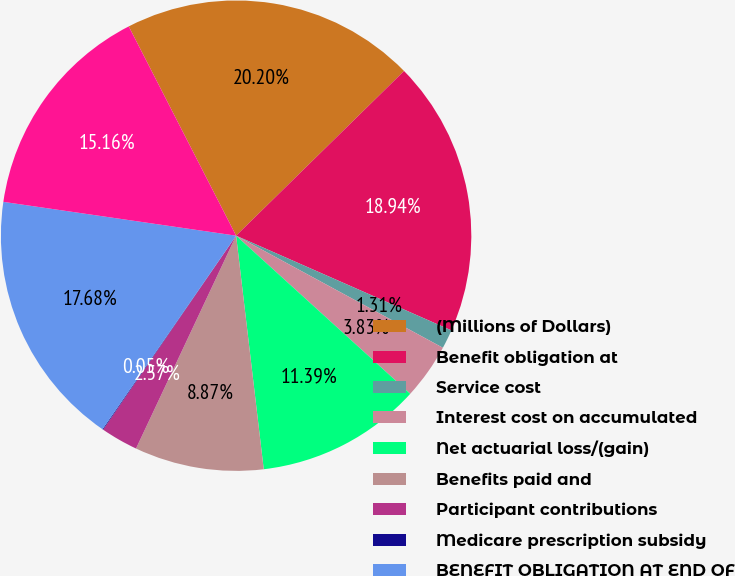Convert chart to OTSL. <chart><loc_0><loc_0><loc_500><loc_500><pie_chart><fcel>(Millions of Dollars)<fcel>Benefit obligation at<fcel>Service cost<fcel>Interest cost on accumulated<fcel>Net actuarial loss/(gain)<fcel>Benefits paid and<fcel>Participant contributions<fcel>Medicare prescription subsidy<fcel>BENEFIT OBLIGATION AT END OF<fcel>Fair value of plan assets at<nl><fcel>20.2%<fcel>18.94%<fcel>1.31%<fcel>3.83%<fcel>11.39%<fcel>8.87%<fcel>2.57%<fcel>0.05%<fcel>17.68%<fcel>15.16%<nl></chart> 